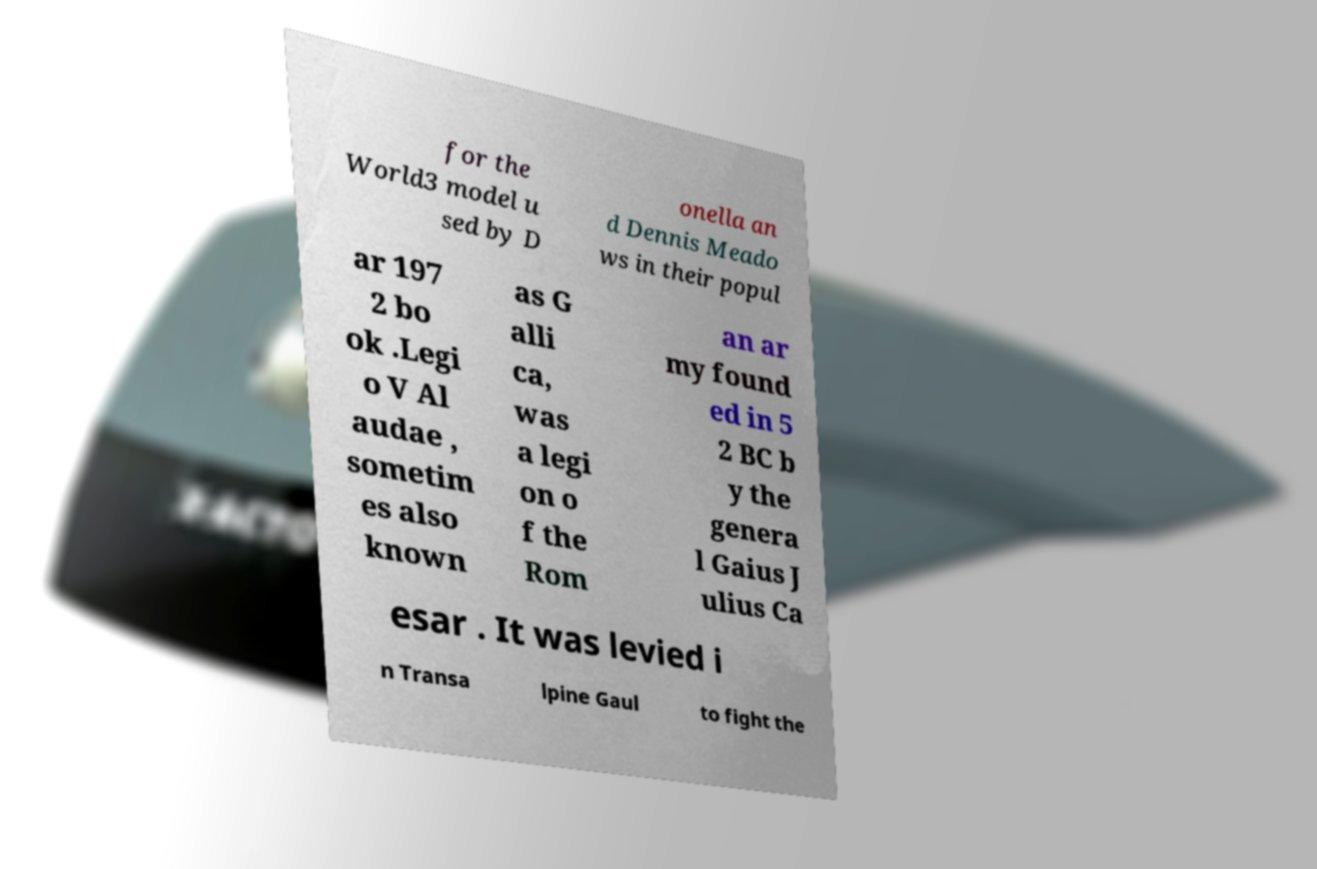Can you read and provide the text displayed in the image?This photo seems to have some interesting text. Can you extract and type it out for me? for the World3 model u sed by D onella an d Dennis Meado ws in their popul ar 197 2 bo ok .Legi o V Al audae , sometim es also known as G alli ca, was a legi on o f the Rom an ar my found ed in 5 2 BC b y the genera l Gaius J ulius Ca esar . It was levied i n Transa lpine Gaul to fight the 